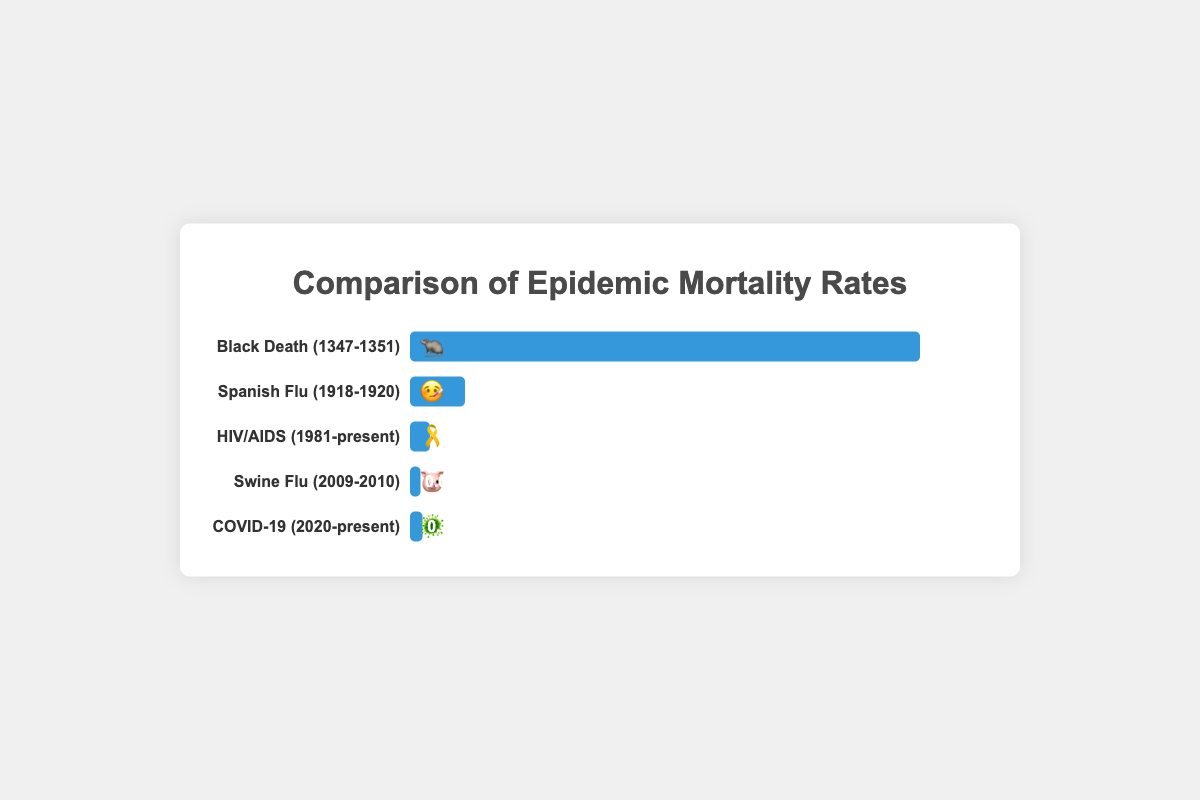What is the title of the chart? The title of the chart is "Comparison of Epidemic Mortality Rates". This is located at the very top of the chart.
Answer: Comparison of Epidemic Mortality Rates Which epidemic has the highest mortality rate? The epidemic with the highest mortality rate is "Black Death (1347-1351)", as indicated by both its largest bar and the adjusted mortality rate value of 30.0%.
Answer: Black Death (1347-1351) Compare the mortality rates of the Spanish Flu and COVID-19. The Spanish Flu has an adjusted mortality rate of 2.7%, whereas COVID-19 has an adjusted mortality rate of 0.15%. The Spanish Flu's rate is higher than that of COVID-19.
Answer: The Spanish Flu's rate is higher How many epidemics have an adjusted mortality rate below 1%? Based on the figure, the Swine Flu (0.02%), HIV/AIDS (0.6%), and COVID-19 (0.15%) all have mortality rates below 1%. This results in a total of 3 epidemics.
Answer: 3 What is the adjusted mortality rate of the Swine Flu? The Swine Flu's adjusted mortality rate is directly shown on the chart as 0.02%. This percentage is displayed next to the bar for the Swine Flu.
Answer: 0.02% What is the average adjusted mortality rate of all epidemics listed? To find the average adjusted mortality rate: (30.0 + 2.7 + 0.6 + 0.02 + 0.15) / 5 = 33.47 / 5 = 6.694%. First sum the rates: 30.0 + 2.7 + 0.6 + 0.02 + 0.15 = 33.47. Then divide by the number of epidemics (5) to get the average.
Answer: 6.694% Arrange the epidemics by their adjusted mortality rate in descending order. The order from highest to lowest adjusted mortality rate is: Black Death (30.0%), Spanish Flu (2.7%), HIV/AIDS (0.6%), COVID-19 (0.15%), and Swine Flu (0.02%). This can be determined by comparing the lengths of the bars and the percentages.
Answer: Black Death, Spanish Flu, HIV/AIDS, COVID-19, Swine Flu Which epidemic is represented by the 🎗️ emoji? The HIV/AIDS epidemic is represented by the 🎗️ emoji. This is located next to the bar labeled with "HIV/AIDS (1981-present)".
Answer: HIV/AIDS 